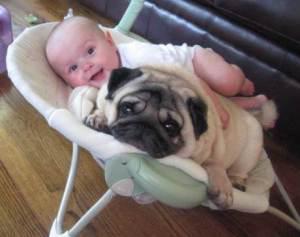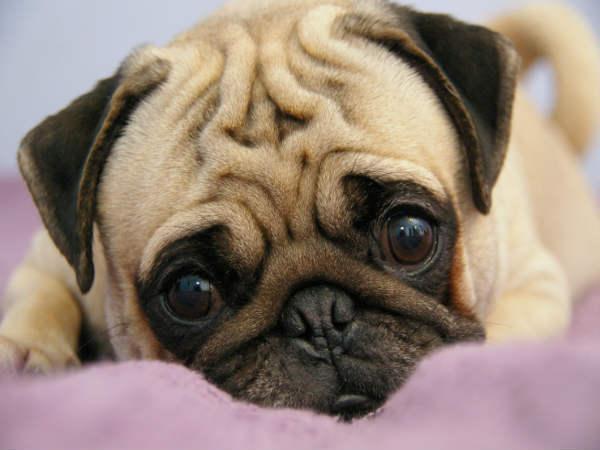The first image is the image on the left, the second image is the image on the right. For the images shown, is this caption "In the left image, a dog is eating some food set up for a human." true? Answer yes or no. No. The first image is the image on the left, the second image is the image on the right. For the images displayed, is the sentence "Atleast one picture contains a bowl with food." factually correct? Answer yes or no. No. 